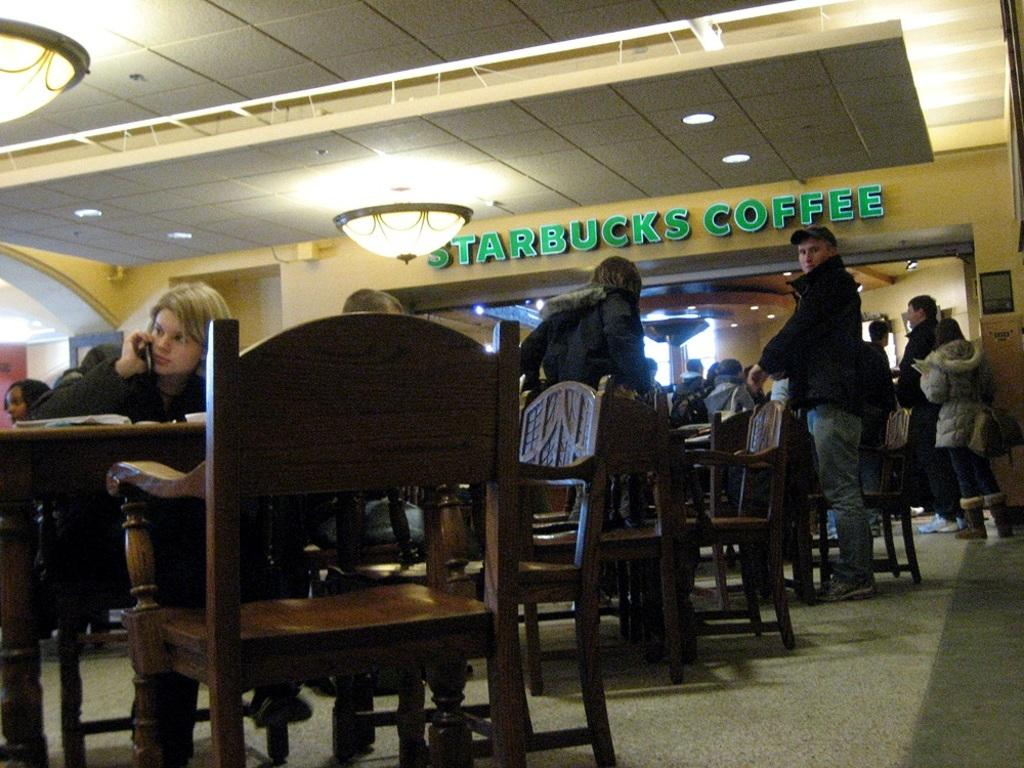What type of establishment is shown in the image? The image depicts a Starbucks coffee shop. What are the people in the image doing? The people in the image are sitting on chairs. What is in front of the people? There is a table in front of the people. What part of the building can be seen in the image? The ceiling is visible in the image. What helps to illuminate the interior of the coffee shop? There is lighting present in the image. What type of pancake is being served on the table in the image? There is no pancake present in the image; it is a Starbucks coffee shop with people sitting at a table. What type of bag is the person sitting on the chair holding? There is no bag visible in the image; the people are sitting on chairs with a table in front of them. 